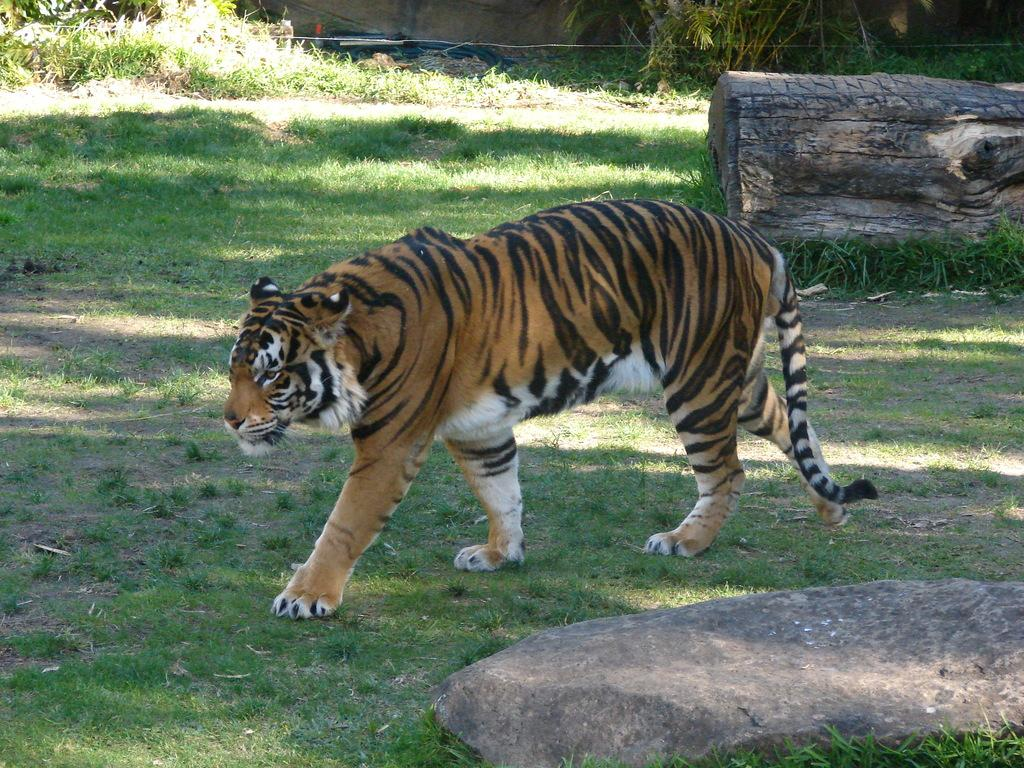What animal is in the image? There is a tiger in the image. What type of terrain is at the bottom of the image? There is grass and stones at the bottom of the image. What can be seen in the background of the image? There is a wall in the background of the image. What object is present in the image that is not part of the tiger or the terrain? There is a tree trunk in the image. What type of lock is holding the tiger in the image? There is no lock present in the image; the tiger is not restrained. Can you see a train passing by in the image? There is no train visible in the image. 